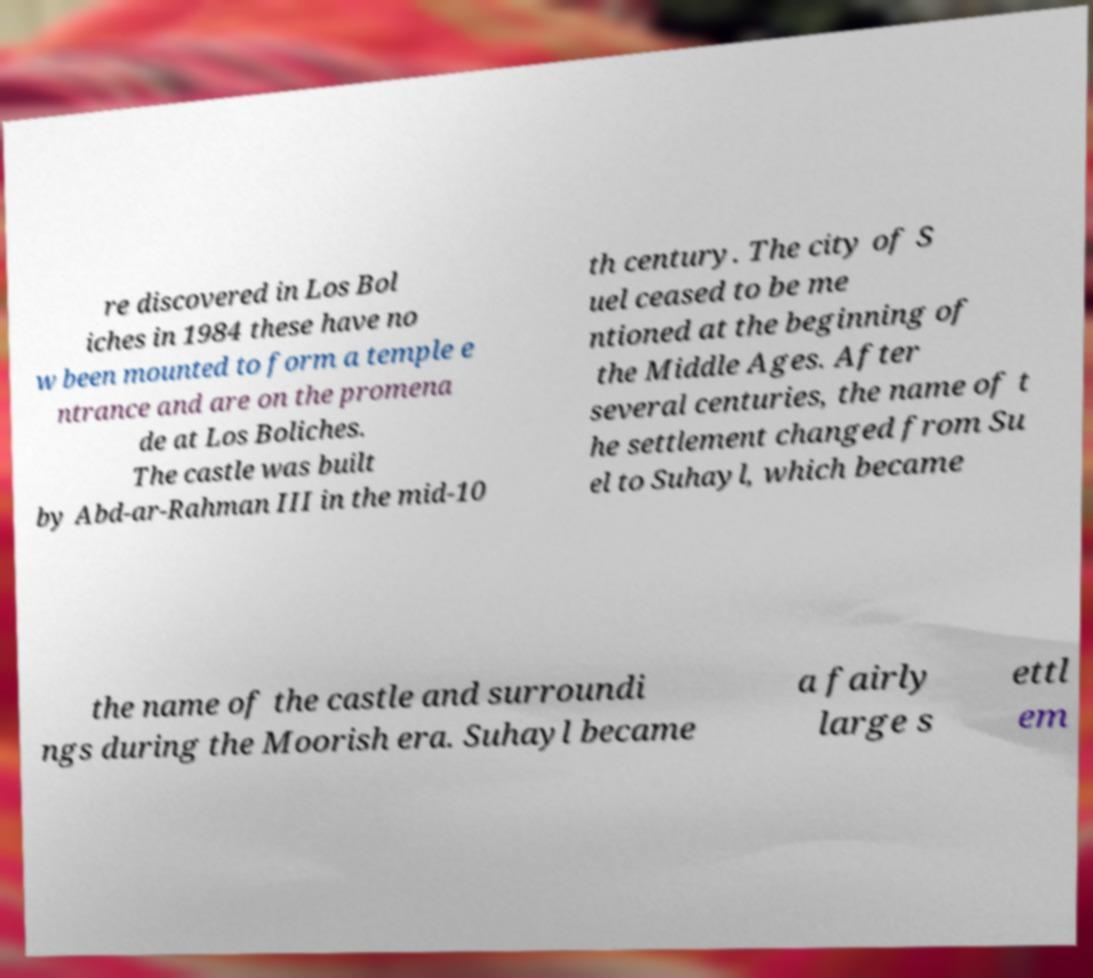There's text embedded in this image that I need extracted. Can you transcribe it verbatim? re discovered in Los Bol iches in 1984 these have no w been mounted to form a temple e ntrance and are on the promena de at Los Boliches. The castle was built by Abd-ar-Rahman III in the mid-10 th century. The city of S uel ceased to be me ntioned at the beginning of the Middle Ages. After several centuries, the name of t he settlement changed from Su el to Suhayl, which became the name of the castle and surroundi ngs during the Moorish era. Suhayl became a fairly large s ettl em 